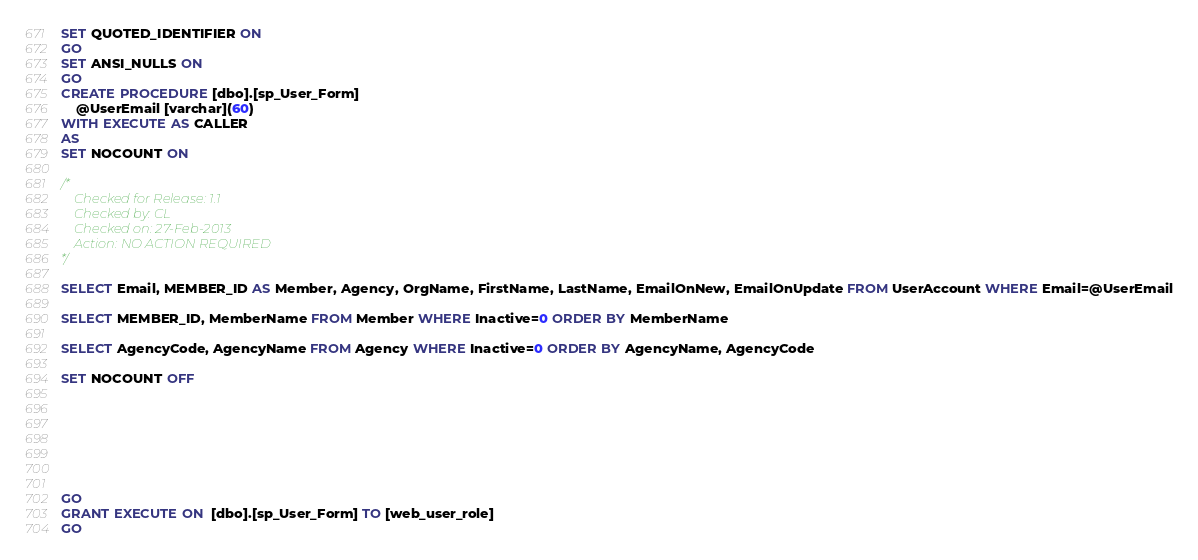Convert code to text. <code><loc_0><loc_0><loc_500><loc_500><_SQL_>SET QUOTED_IDENTIFIER ON
GO
SET ANSI_NULLS ON
GO
CREATE PROCEDURE [dbo].[sp_User_Form]
	@UserEmail [varchar](60)
WITH EXECUTE AS CALLER
AS
SET NOCOUNT ON

/*
	Checked for Release: 1.1
	Checked by: CL
	Checked on: 27-Feb-2013
	Action: NO ACTION REQUIRED
*/

SELECT Email, MEMBER_ID AS Member, Agency, OrgName, FirstName, LastName, EmailOnNew, EmailOnUpdate FROM UserAccount WHERE Email=@UserEmail

SELECT MEMBER_ID, MemberName FROM Member WHERE Inactive=0 ORDER BY MemberName

SELECT AgencyCode, AgencyName FROM Agency WHERE Inactive=0 ORDER BY AgencyName, AgencyCode

SET NOCOUNT OFF







GO
GRANT EXECUTE ON  [dbo].[sp_User_Form] TO [web_user_role]
GO
</code> 